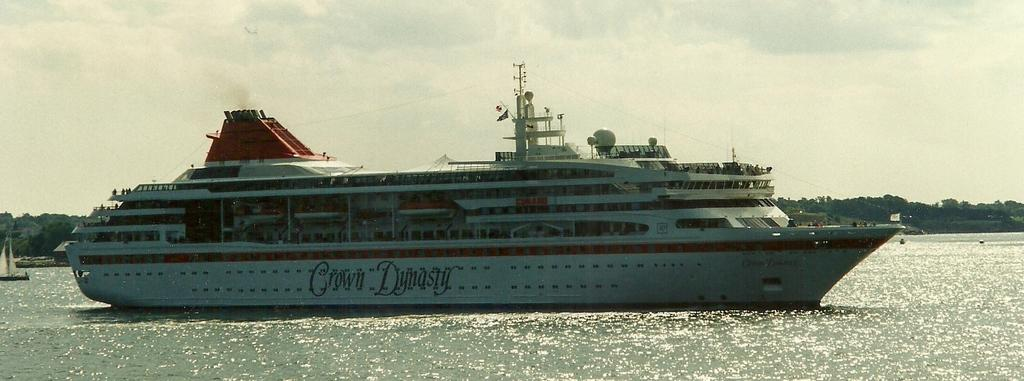What is the main subject of the image? The main subject of the image is a ship. Where is the ship located? The ship is on water. What can be seen in the background of the image? There are trees and the sky visible in the background of the image. What type of crown is the ship wearing in the image? The ship is not wearing a crown in the image, as ships do not wear crowns. 